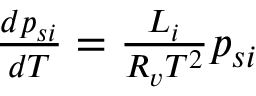Convert formula to latex. <formula><loc_0><loc_0><loc_500><loc_500>\begin{array} { r } { { \frac { d p _ { s i } } { d T } } = \frac { L _ { i } } { R _ { v } T ^ { 2 } } p _ { s i } } \end{array}</formula> 